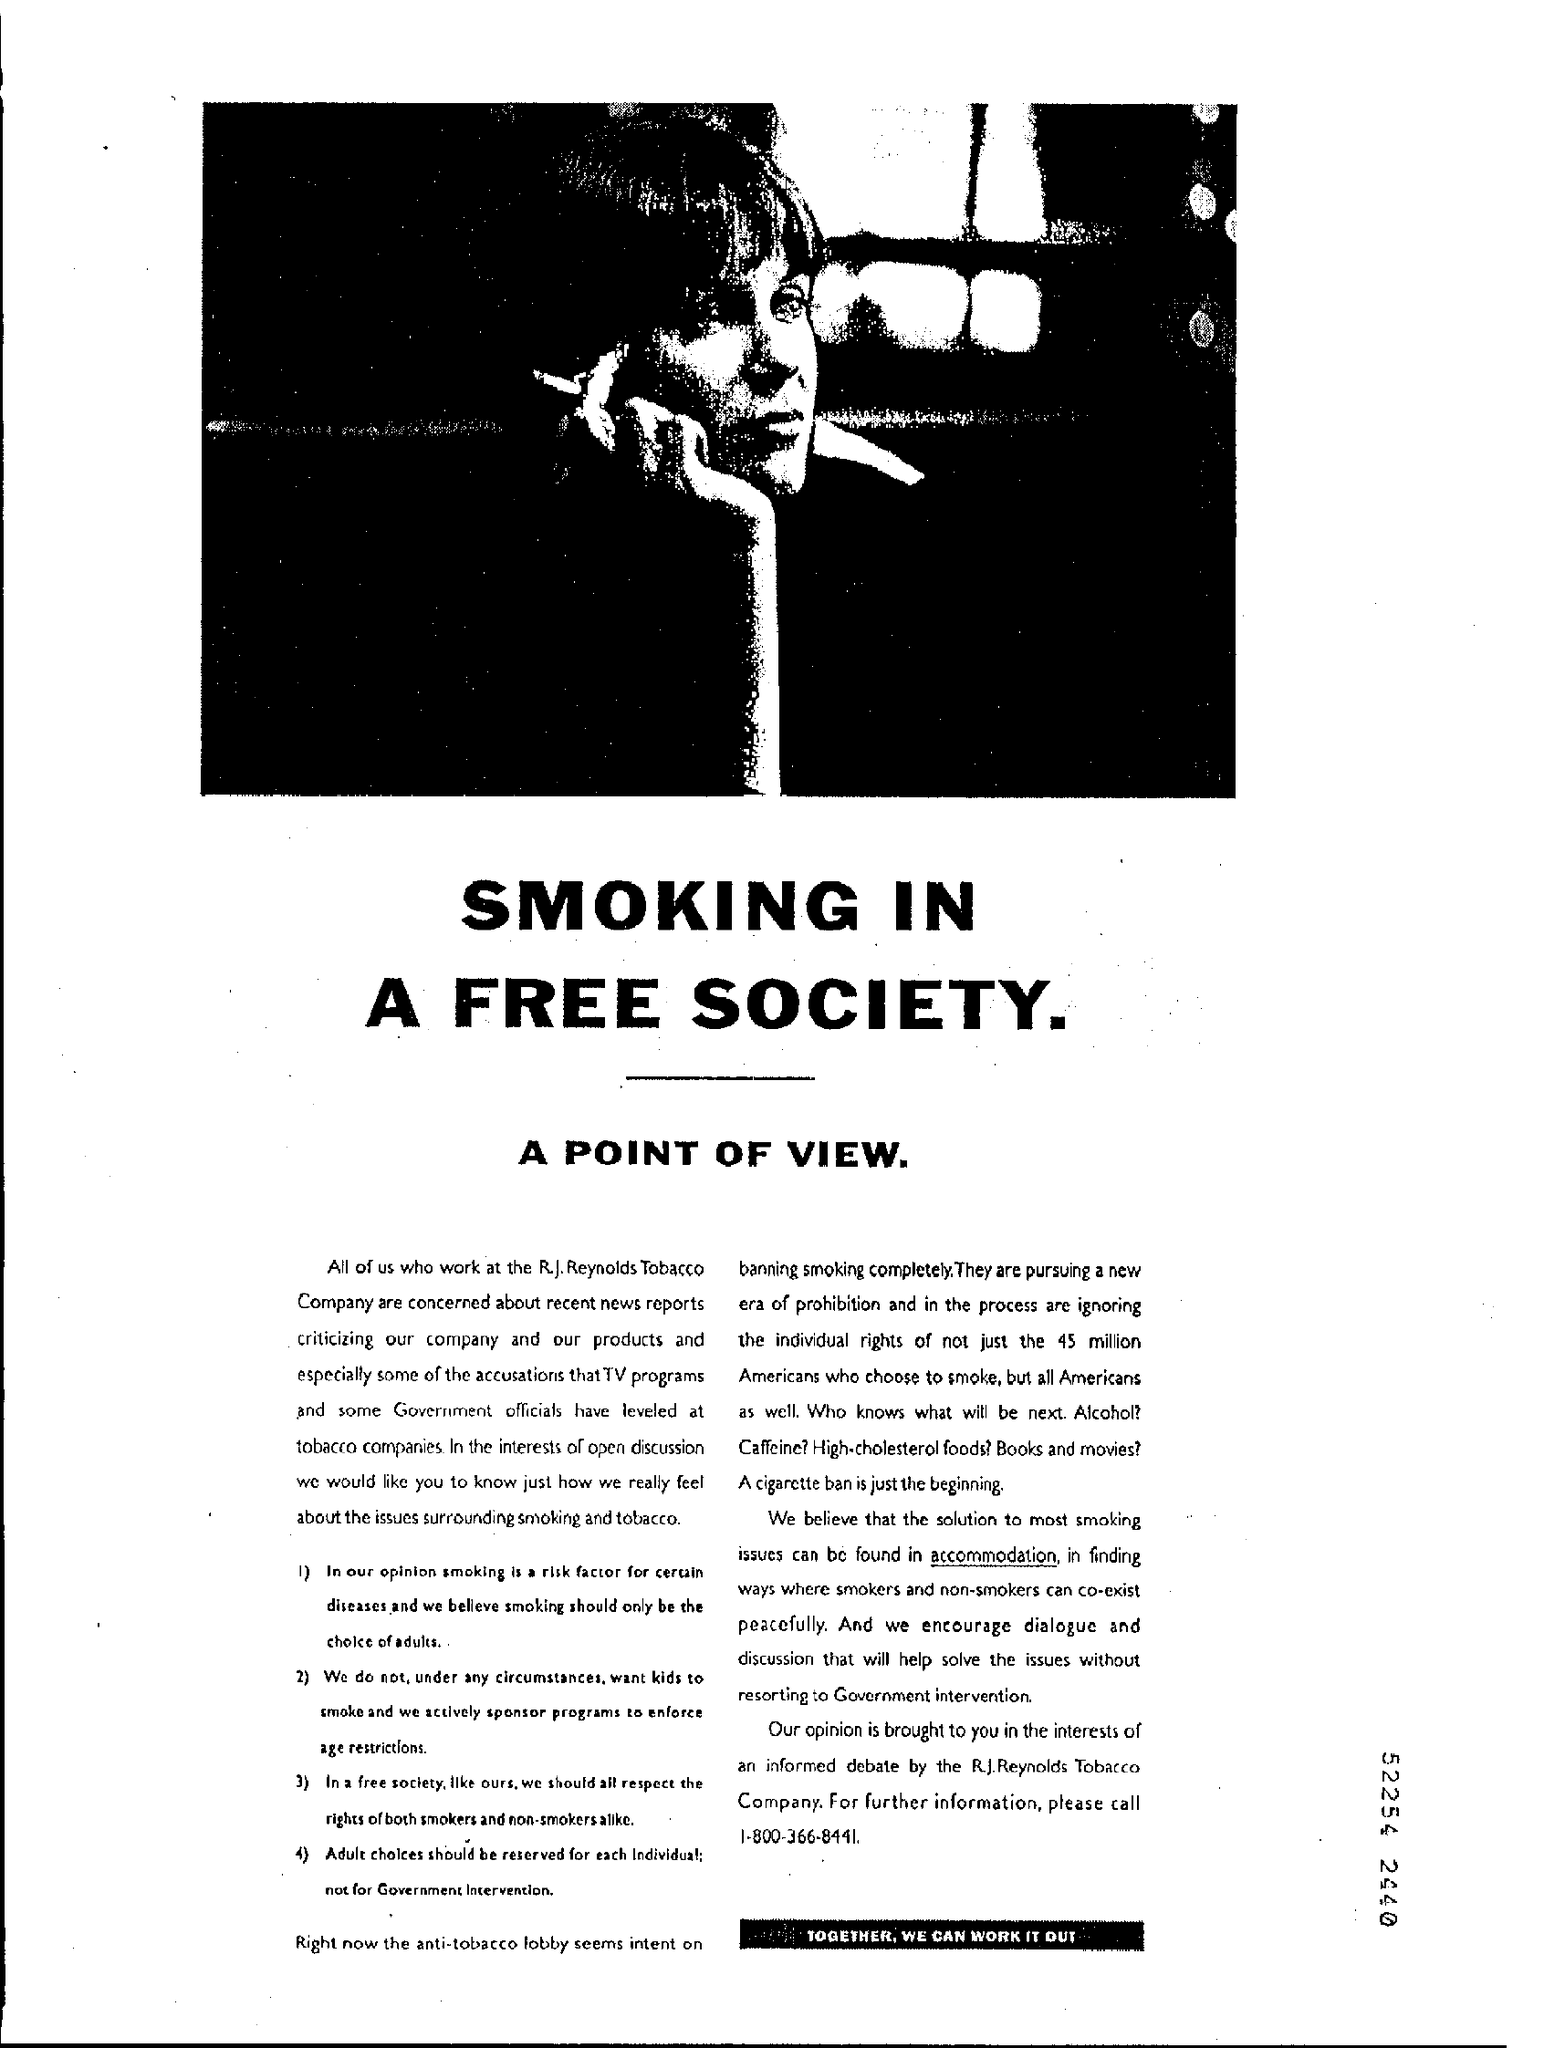Give some essential details in this illustration. The contact number provided is 1-800-366-8441. The company mentioned is R.J. Reynolds Tobacco Company. 